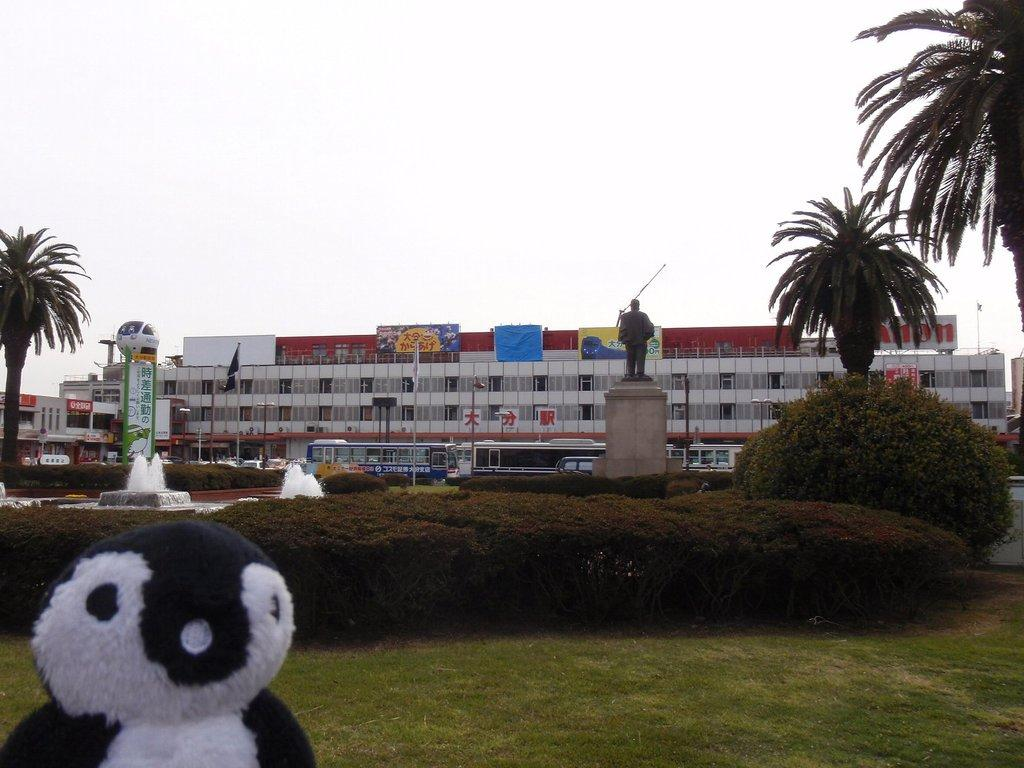What object can be seen on the left side of the image? There is a soft toy on the left side of the image. What can be seen in the background of the image? The sky, buildings, trees, plants, grass, vehicles, and a fountain are visible in the background of the image. Can you describe the setting of the image? The image appears to be set in an outdoor area with a mix of natural and urban elements in the background. Is there a chair next to the soft toy in the image? There is no chair visible next to the soft toy in the image. Can you tell me what advice your uncle gives about the soft toy in the image? The image does not contain any information about an uncle or any advice related to the soft toy. 